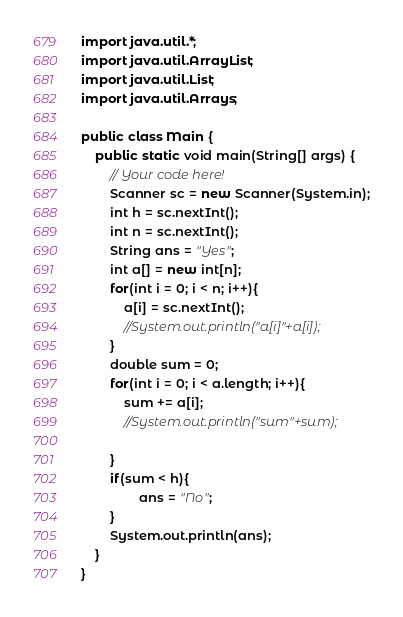<code> <loc_0><loc_0><loc_500><loc_500><_Java_>import java.util.*;
import java.util.ArrayList;
import java.util.List;
import java.util.Arrays;

public class Main {
    public static void main(String[] args) {
        // Your code here!
        Scanner sc = new Scanner(System.in);
        int h = sc.nextInt();
        int n = sc.nextInt();
        String ans = "Yes";
        int a[] = new int[n]; 
        for(int i = 0; i < n; i++){
            a[i] = sc.nextInt();
            //System.out.println("a[i]"+a[i]);
        }
        double sum = 0;
        for(int i = 0; i < a.length; i++){
            sum += a[i];
            //System.out.println("sum"+sum);
            
        }
        if(sum < h){
                ans = "No";
        }
        System.out.println(ans);
    }
}</code> 